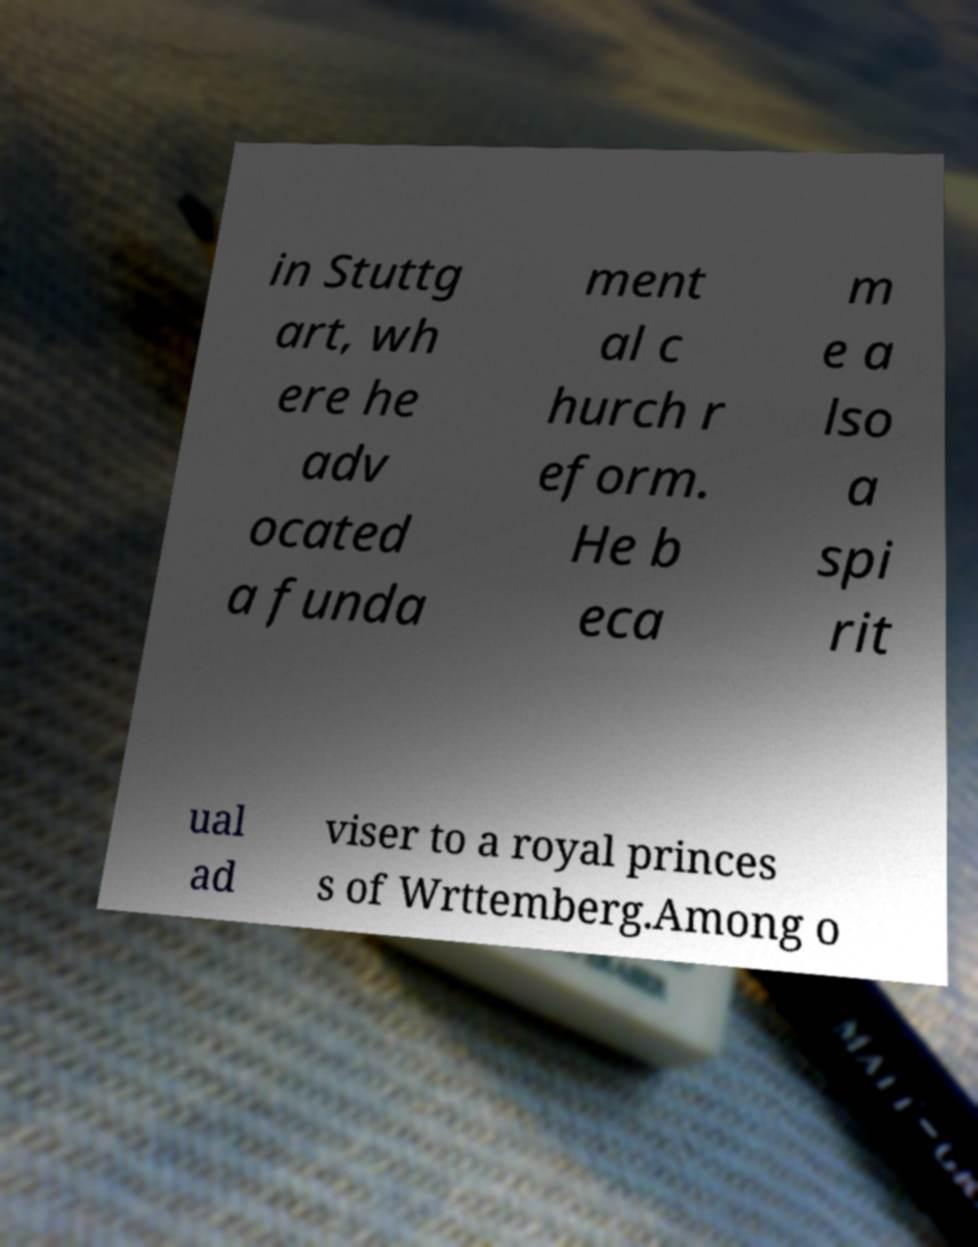There's text embedded in this image that I need extracted. Can you transcribe it verbatim? in Stuttg art, wh ere he adv ocated a funda ment al c hurch r eform. He b eca m e a lso a spi rit ual ad viser to a royal princes s of Wrttemberg.Among o 